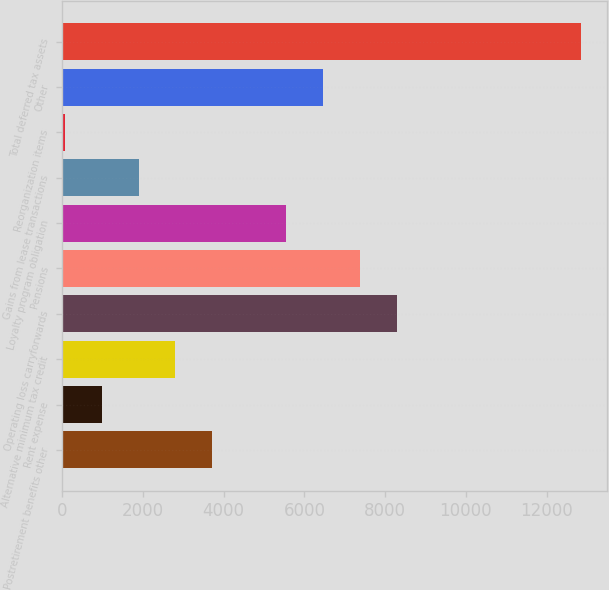Convert chart. <chart><loc_0><loc_0><loc_500><loc_500><bar_chart><fcel>Postretirement benefits other<fcel>Rent expense<fcel>Alternative minimum tax credit<fcel>Operating loss carryforwards<fcel>Pensions<fcel>Loyalty program obligation<fcel>Gains from lease transactions<fcel>Reorganization items<fcel>Other<fcel>Total deferred tax assets<nl><fcel>3720.4<fcel>978.1<fcel>2806.3<fcel>8290.9<fcel>7376.8<fcel>5548.6<fcel>1892.2<fcel>64<fcel>6462.7<fcel>12861.4<nl></chart> 